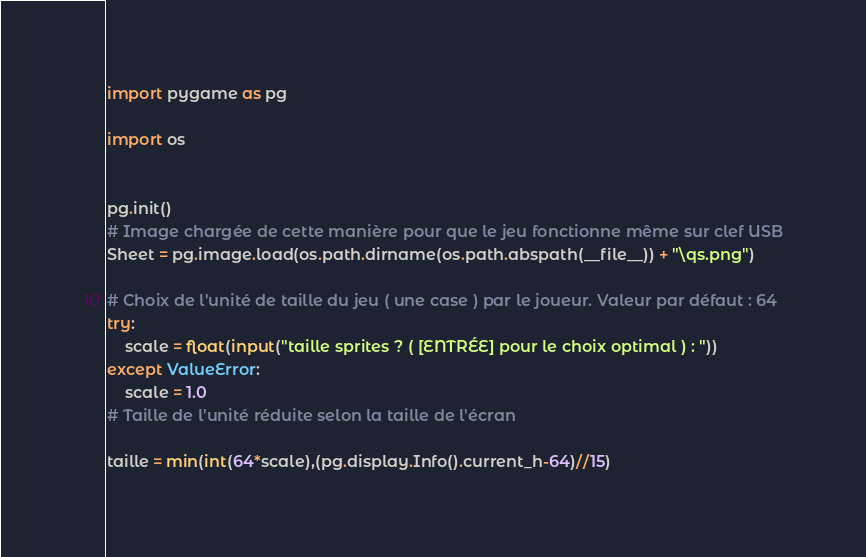<code> <loc_0><loc_0><loc_500><loc_500><_Python_>import pygame as pg

import os


pg.init()
# Image chargée de cette manière pour que le jeu fonctionne même sur clef USB
Sheet = pg.image.load(os.path.dirname(os.path.abspath(__file__)) + "\qs.png")

# Choix de l'unité de taille du jeu ( une case ) par le joueur. Valeur par défaut : 64
try:
	scale = float(input("taille sprites ? ( [ENTRÉE] pour le choix optimal ) : "))
except ValueError:
	scale = 1.0
# Taille de l'unité réduite selon la taille de l'écran

taille = min(int(64*scale),(pg.display.Info().current_h-64)//15)
</code> 